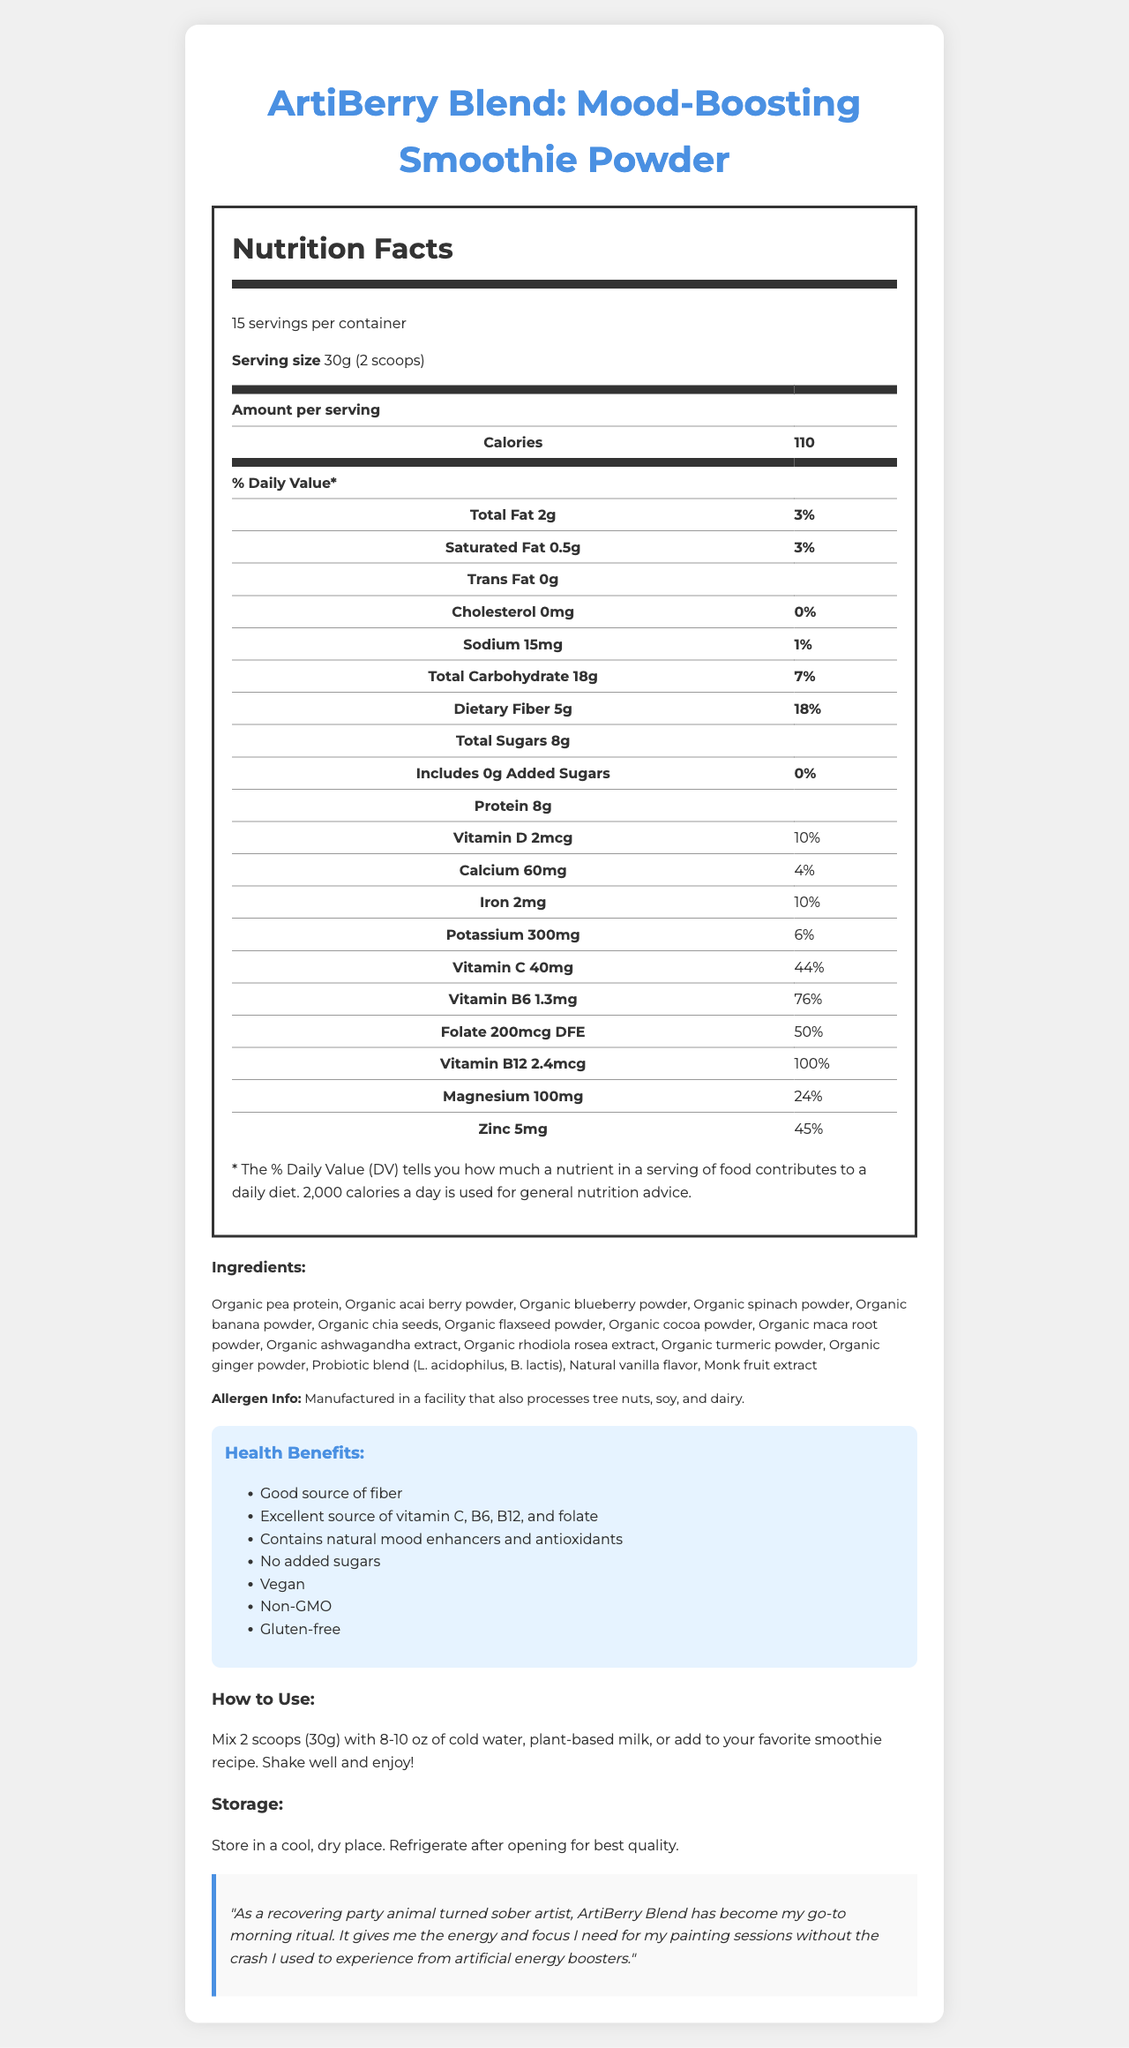what is the serving size of the ArtiBerry Blend? The serving size is listed at the very top of the nutrition facts section as "30g (2 scoops)".
Answer: 30g (2 scoops) how many servings are there in one container? The number of servings per container is mentioned right below the product name in the servings per container section.
Answer: 15 what is the amount of dietary fiber per serving? The amount of dietary fiber is listed in the nutrition facts table under the Total Carbohydrate section.
Answer: 5g how much protein does one serving contain? The protein content per serving is stated near the bottom of the nutrition facts table.
Answer: 8g name three ingredients in the ArtiBerry Blend. The ingredients list includes a detailed list of all ingredients used in the product.
Answer: Organic pea protein, Organic acai berry powder, Organic blueberry powder which vitamin has the highest daily value percentage in one serving of ArtiBerry Blend? A. Vitamin C B. Vitamin B6 C. Folate D. Vitamin B12 Vitamin B12 has the highest daily value percentage at 100%.
Answer: D what is the total carbohydrate content as a percentage of daily value per serving? A. 4% B. 7% C. 10% D. 12% The total carbohydrate content per serving is listed as 18g, which is equivalent to 7% of the daily value.
Answer: B is ArtiBerry Blend vegan? Under the Health Benefits section, one of the claims is that the product is "Vegan".
Answer: Yes does ArtiBerry Blend contain any added sugars? The nutrition facts table specifies "0g" for added sugars and "0%" for daily value.
Answer: No does the ArtiBerry Blend provide any probiotics? The ingredient list includes a Probiotic blend (L. acidophilus, B. lactis).
Answer: Yes does the document indicate any allergens? The allergen information states that it is "Manufactured in a facility that also processes tree nuts, soy, and dairy."
Answer: Yes how should the ArtiBerry Blend be stored after opening? The storage instructions mention refrigeration after opening for maintaining the best quality.
Answer: Refrigerate after opening for best quality what are some health benefits of the ArtiBerry Blend mentioned in the document? These health benefits are listed under the Health Benefits section.
Answer: Good source of fiber, Excellent source of vitamin C, B6, B12, and folate, Contains natural mood enhancers and antioxidants, No added sugars, Vegan, Non-GMO, Gluten-free what gives the ArtiBerry Blend its natural sweetness? The ingredient list includes monk fruit extract, which is known for its natural sweetness.
Answer: Monk fruit extract summarize the document. The document provides comprehensive information about the ArtiBerry Blend, including nutritional content, ingredients, health benefits, usage, storage, and a testimonial praising its energy-boosting properties for a healthy lifestyle.
Answer: The document presents the nutrition facts, ingredients, health benefits, usage instructions, storage guidelines, and a testimonial for the ArtiBerry Blend: Mood-Boosting Smoothie Powder. It highlights features such as being vegan, non-GMO, gluten-free, containing natural mood enhancers and antioxidants, and having no added sugars. The product boasts various vitamins and minerals and provides instructions on using and storing the blend. Testimonials emphasize its energy-boosting properties beneficial for a healthy lifestyle. which company produces ArtiBerry Blend? The document does not provide the company's name that produces ArtiBerry Blend.
Answer: Not enough information 